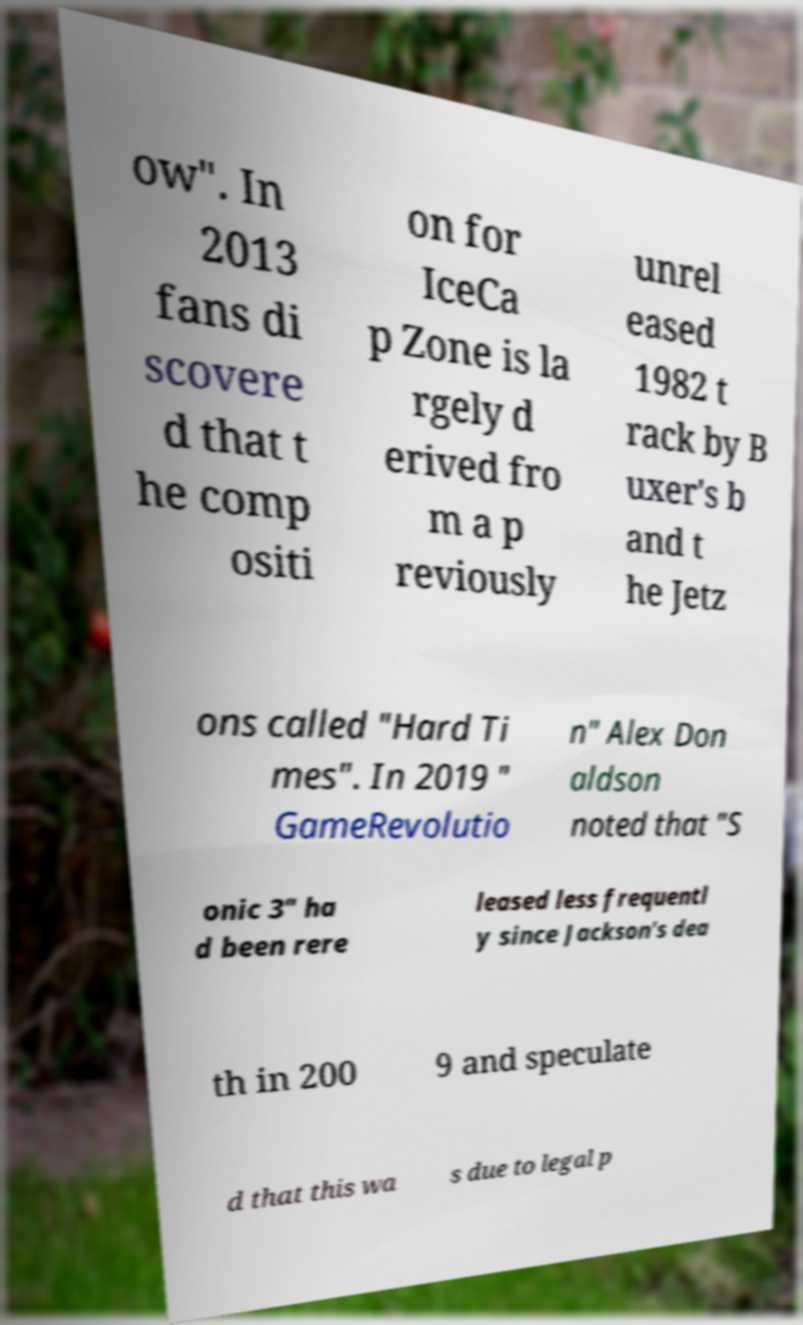Please read and relay the text visible in this image. What does it say? ow". In 2013 fans di scovere d that t he comp ositi on for IceCa p Zone is la rgely d erived fro m a p reviously unrel eased 1982 t rack by B uxer's b and t he Jetz ons called "Hard Ti mes". In 2019 " GameRevolutio n" Alex Don aldson noted that "S onic 3" ha d been rere leased less frequentl y since Jackson's dea th in 200 9 and speculate d that this wa s due to legal p 